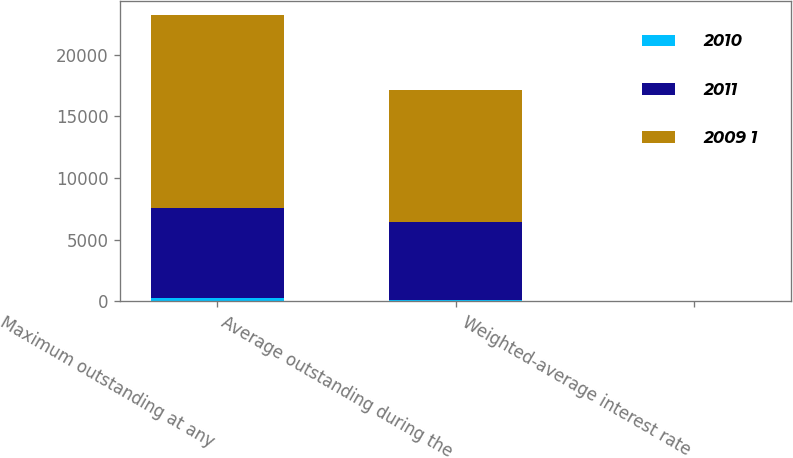Convert chart. <chart><loc_0><loc_0><loc_500><loc_500><stacked_bar_chart><ecel><fcel>Maximum outstanding at any<fcel>Average outstanding during the<fcel>Weighted-average interest rate<nl><fcel>2010<fcel>271<fcel>113<fcel>0.47<nl><fcel>2011<fcel>7275<fcel>6339<fcel>0.32<nl><fcel>2009 1<fcel>15645<fcel>10691<fcel>1.26<nl></chart> 